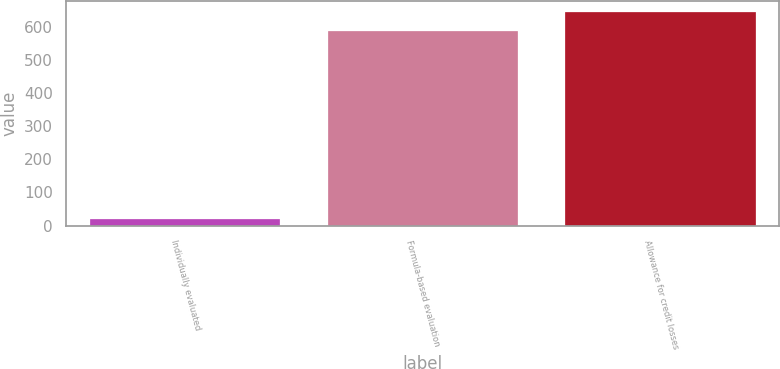Convert chart to OTSL. <chart><loc_0><loc_0><loc_500><loc_500><bar_chart><fcel>Individually evaluated<fcel>Formula-based evaluation<fcel>Allowance for credit losses<nl><fcel>20<fcel>585<fcel>643.5<nl></chart> 